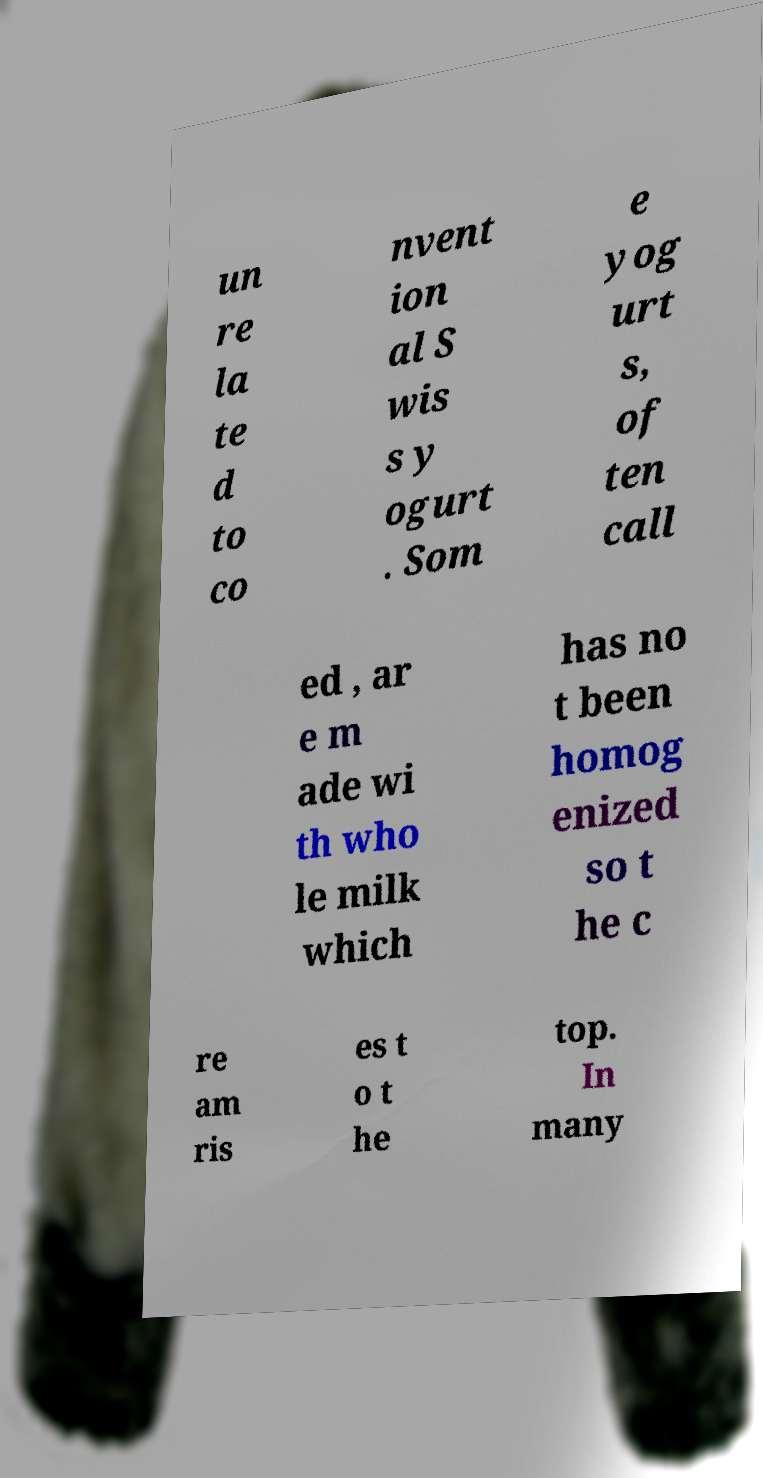Please read and relay the text visible in this image. What does it say? un re la te d to co nvent ion al S wis s y ogurt . Som e yog urt s, of ten call ed , ar e m ade wi th who le milk which has no t been homog enized so t he c re am ris es t o t he top. In many 